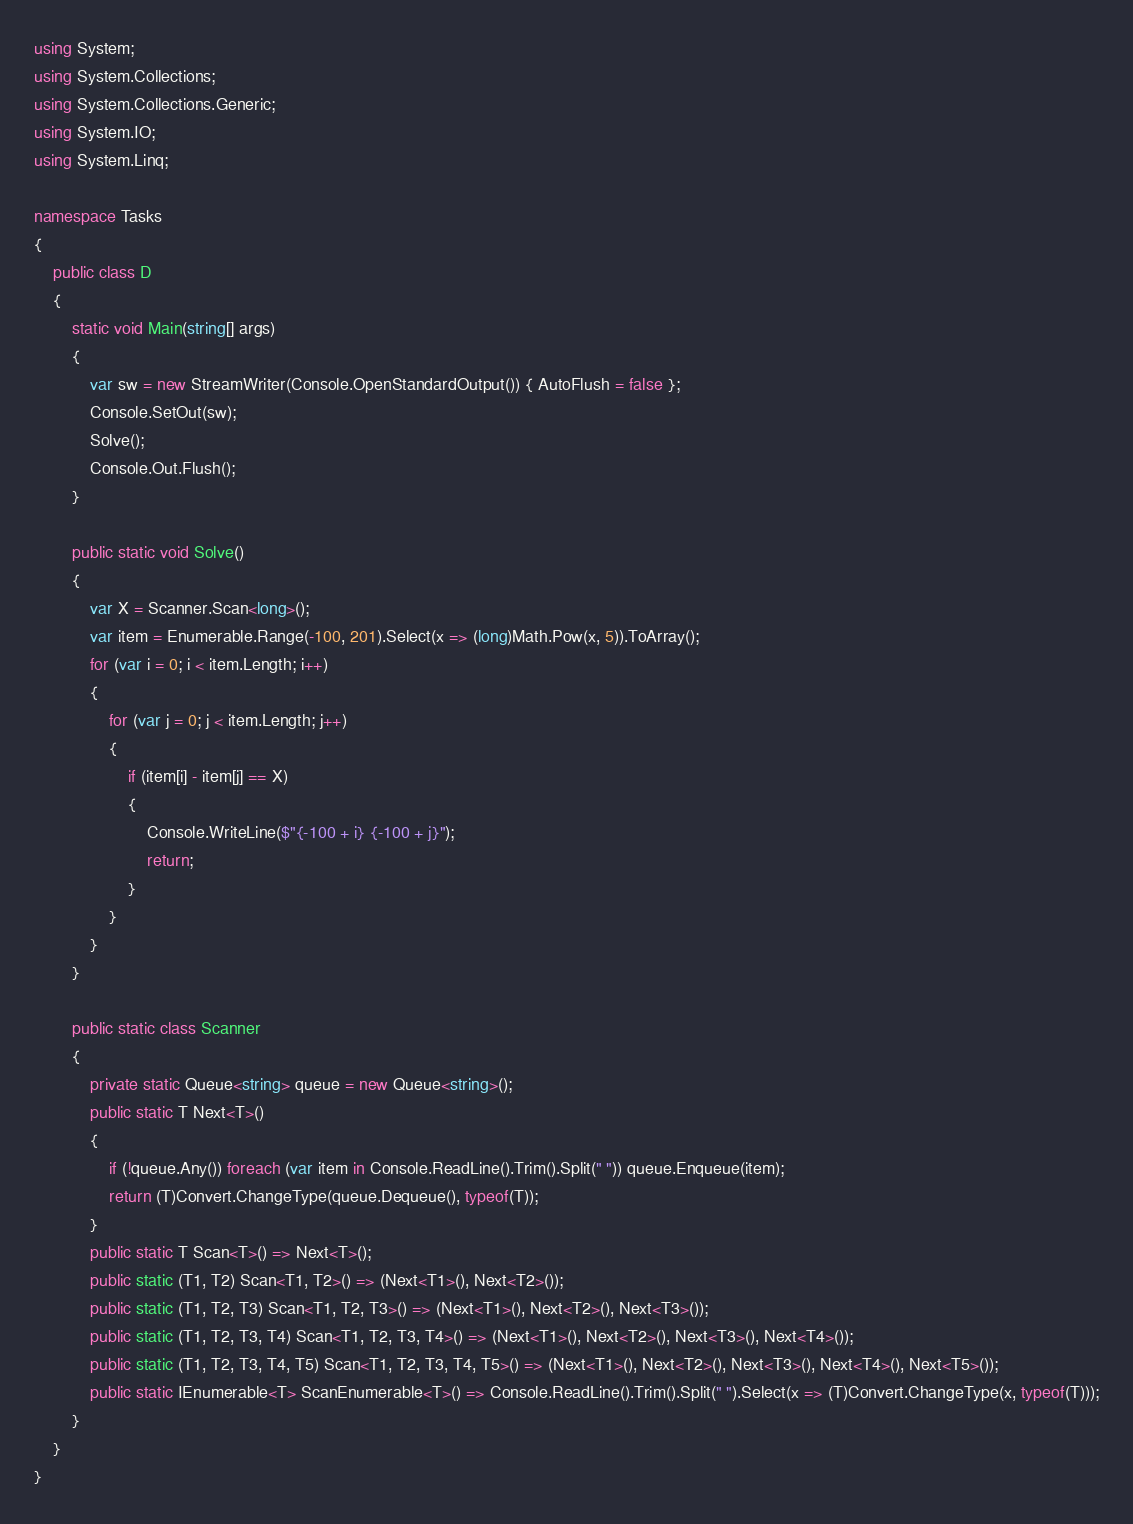<code> <loc_0><loc_0><loc_500><loc_500><_C#_>using System;
using System.Collections;
using System.Collections.Generic;
using System.IO;
using System.Linq;

namespace Tasks
{
    public class D
    {
        static void Main(string[] args)
        {
            var sw = new StreamWriter(Console.OpenStandardOutput()) { AutoFlush = false };
            Console.SetOut(sw);
            Solve();
            Console.Out.Flush();
        }

        public static void Solve()
        {
            var X = Scanner.Scan<long>();
            var item = Enumerable.Range(-100, 201).Select(x => (long)Math.Pow(x, 5)).ToArray();
            for (var i = 0; i < item.Length; i++)
            {
                for (var j = 0; j < item.Length; j++)
                {
                    if (item[i] - item[j] == X)
                    {
                        Console.WriteLine($"{-100 + i} {-100 + j}");
                        return;
                    }
                }
            }
        }

        public static class Scanner
        {
            private static Queue<string> queue = new Queue<string>();
            public static T Next<T>()
            {
                if (!queue.Any()) foreach (var item in Console.ReadLine().Trim().Split(" ")) queue.Enqueue(item);
                return (T)Convert.ChangeType(queue.Dequeue(), typeof(T));
            }
            public static T Scan<T>() => Next<T>();
            public static (T1, T2) Scan<T1, T2>() => (Next<T1>(), Next<T2>());
            public static (T1, T2, T3) Scan<T1, T2, T3>() => (Next<T1>(), Next<T2>(), Next<T3>());
            public static (T1, T2, T3, T4) Scan<T1, T2, T3, T4>() => (Next<T1>(), Next<T2>(), Next<T3>(), Next<T4>());
            public static (T1, T2, T3, T4, T5) Scan<T1, T2, T3, T4, T5>() => (Next<T1>(), Next<T2>(), Next<T3>(), Next<T4>(), Next<T5>());
            public static IEnumerable<T> ScanEnumerable<T>() => Console.ReadLine().Trim().Split(" ").Select(x => (T)Convert.ChangeType(x, typeof(T)));
        }
    }
}
</code> 